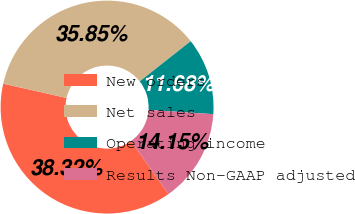Convert chart to OTSL. <chart><loc_0><loc_0><loc_500><loc_500><pie_chart><fcel>New orders<fcel>Net sales<fcel>Operating income<fcel>Results Non-GAAP adjusted<nl><fcel>38.32%<fcel>35.85%<fcel>11.68%<fcel>14.15%<nl></chart> 